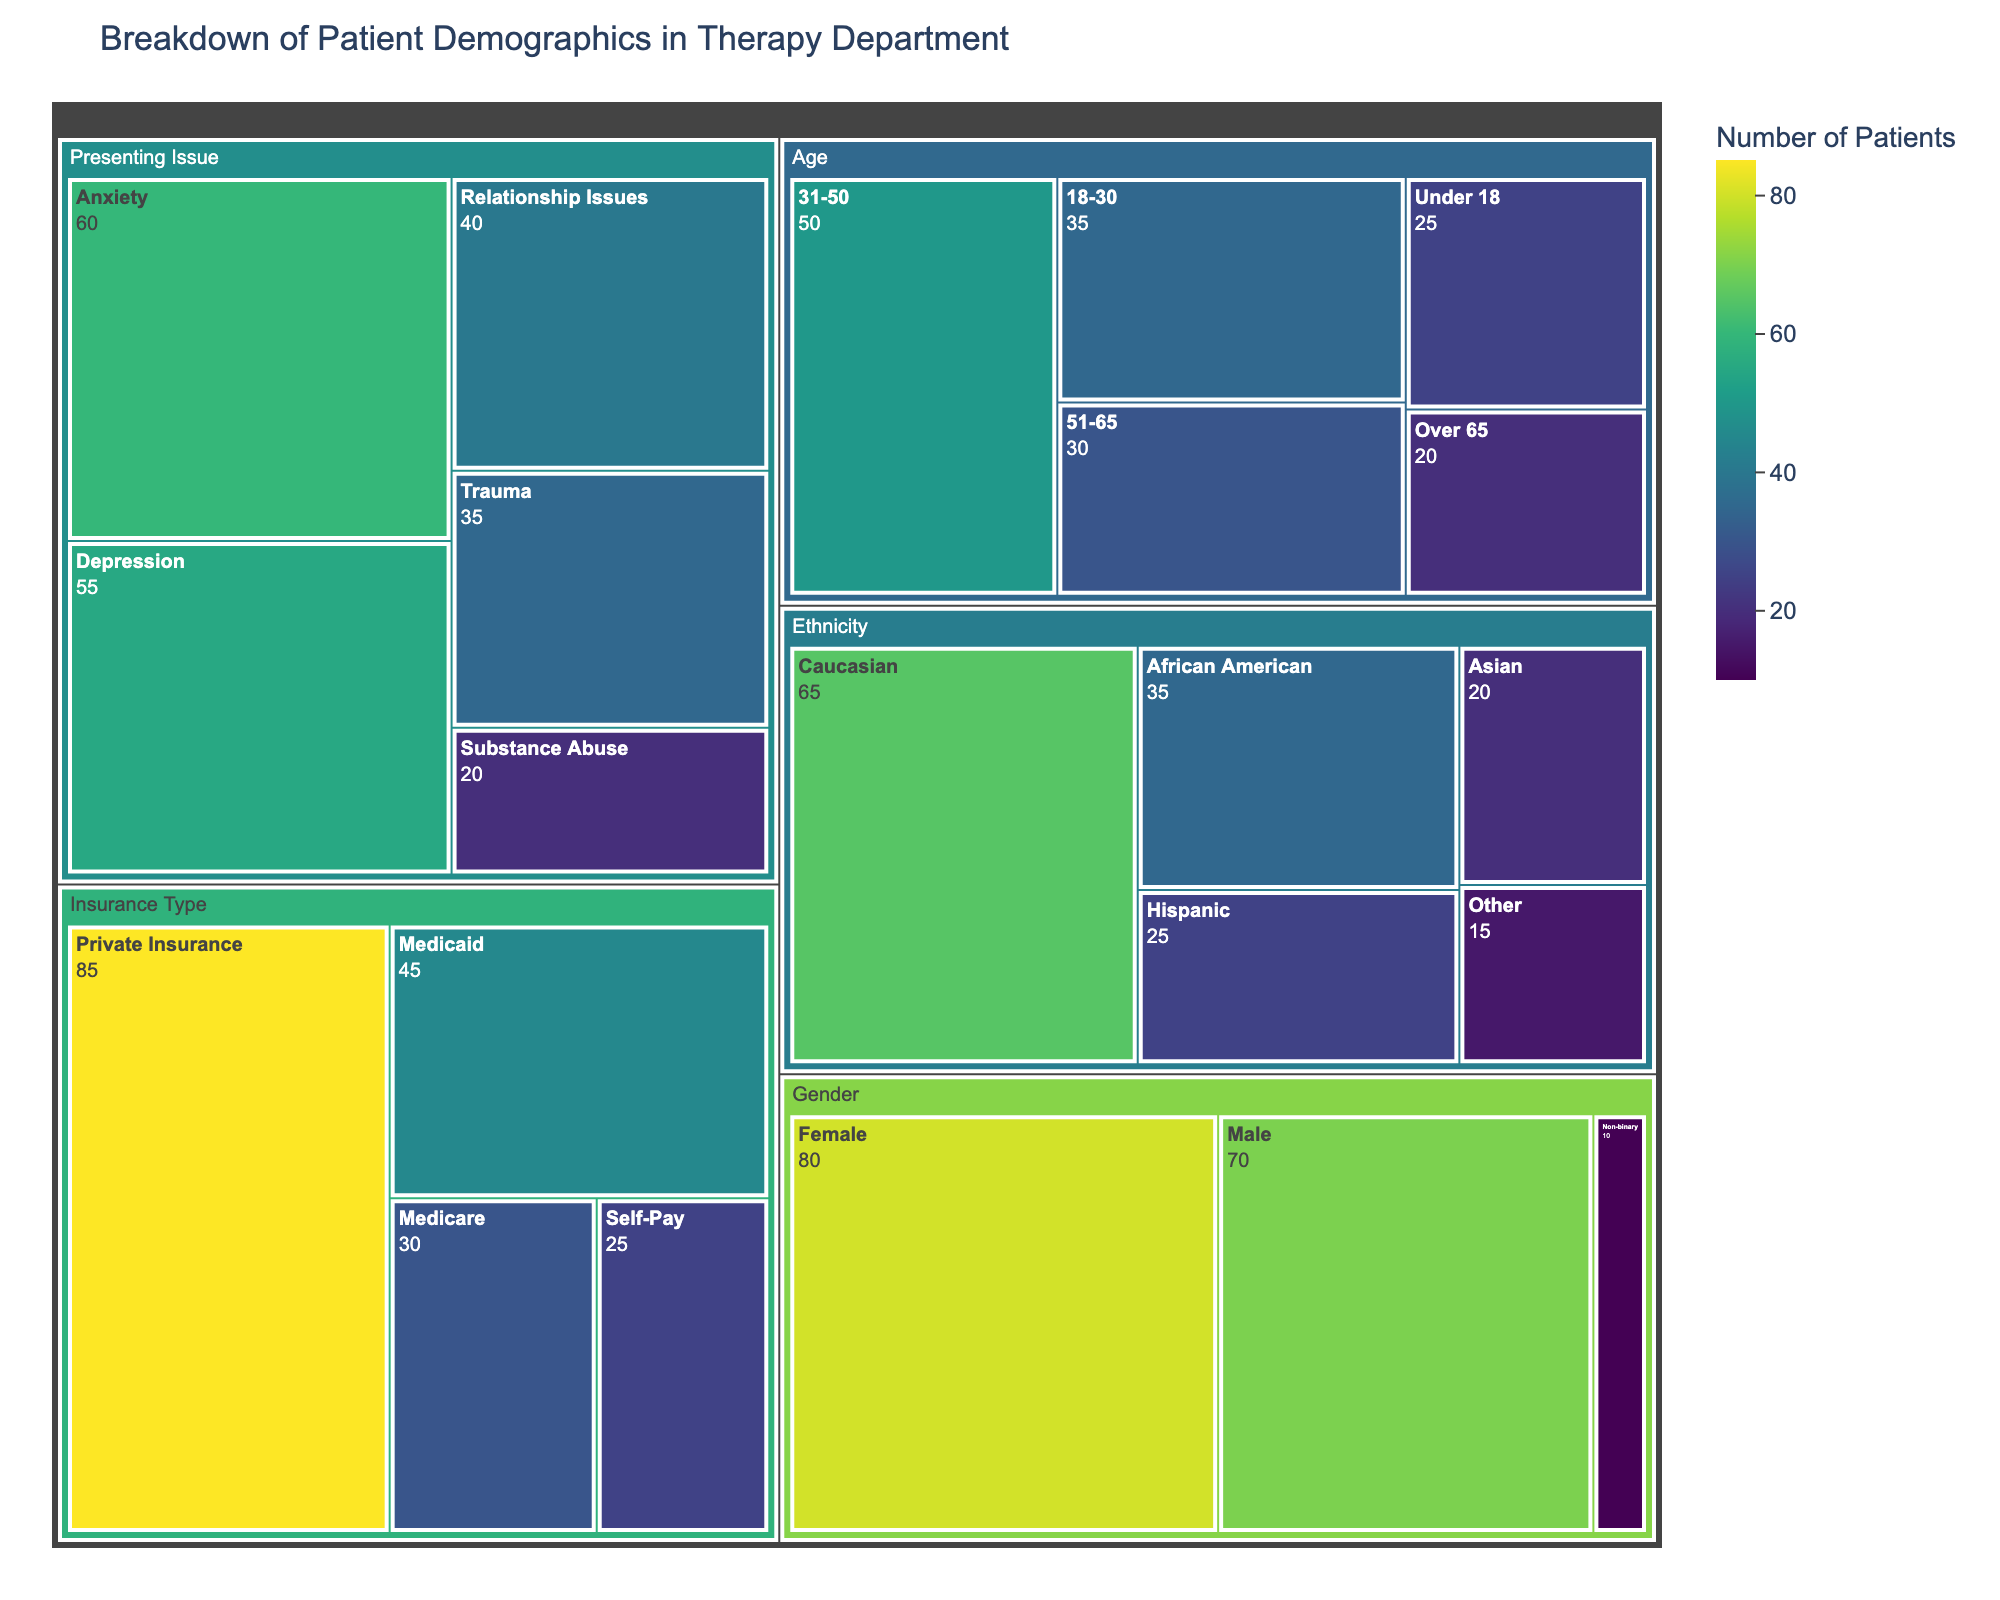What's the title of the treemap? Look at the top of the treemap where the title is usually placed. The title describes the overall theme or subject of the visualization.
Answer: Breakdown of Patient Demographics in Therapy Department Which age group has the highest number of patients? Find the section categorized under 'Age' and identify the subcategory with the largest area, indicative of the highest value. Here, '31-50' has the largest area.
Answer: 31-50 What is the total number of patients in the 18-30 and 31-50 age groups combined? Look at the values for '18-30' and '31-50' under the 'Age' category. Add these two values together: 35 (18-30) + 50 (31-50).
Answer: 85 Which gender category has the smallest number of patients? Under the 'Gender' category, identify the subcategory with the smallest area, indicative of the lowest value. Here, 'Non-binary' has the smallest area.
Answer: Non-binary What is the difference in patient numbers between those with private insurance and those with Medicaid? Locate the values under 'Insurance Type' for 'Private Insurance' and 'Medicaid'. Subtract the Medicaid value from the Private Insurance value: 85 (Private Insurance) - 45 (Medicaid).
Answer: 40 How does the number of female patients compare to male patients? Check the areas under the 'Gender' category for 'Female' and 'Male'. Compare their values (80 for Female, 70 for Male).
Answer: Female patients are more than male patients What is the total number of patients represented in the treemap? Sum all the values provided in the dataset across all categories and subcategories.
Answer: 500 Which presenting issue is the most common among patients? Under 'Presenting Issue', look for the subcategory with the largest area. Here, 'Anxiety' has the largest area.
Answer: Anxiety How many more patients have presenting issues related to trauma compared to substance abuse? Find the values for 'Trauma' and 'Substance Abuse' under the 'Presenting Issue' category. Calculate the difference: 35 (Trauma) - 20 (Substance Abuse).
Answer: 15 In the 'Ethnicity' category, which two ethnic groups have the closest patient numbers? Compare the values in the 'Ethnicity' category and identify the two groups with the most similar numbers. Here, 'Hispanic' (25) and 'Asian' (20) are closest, with a difference of 5.
Answer: Hispanic and Asian 